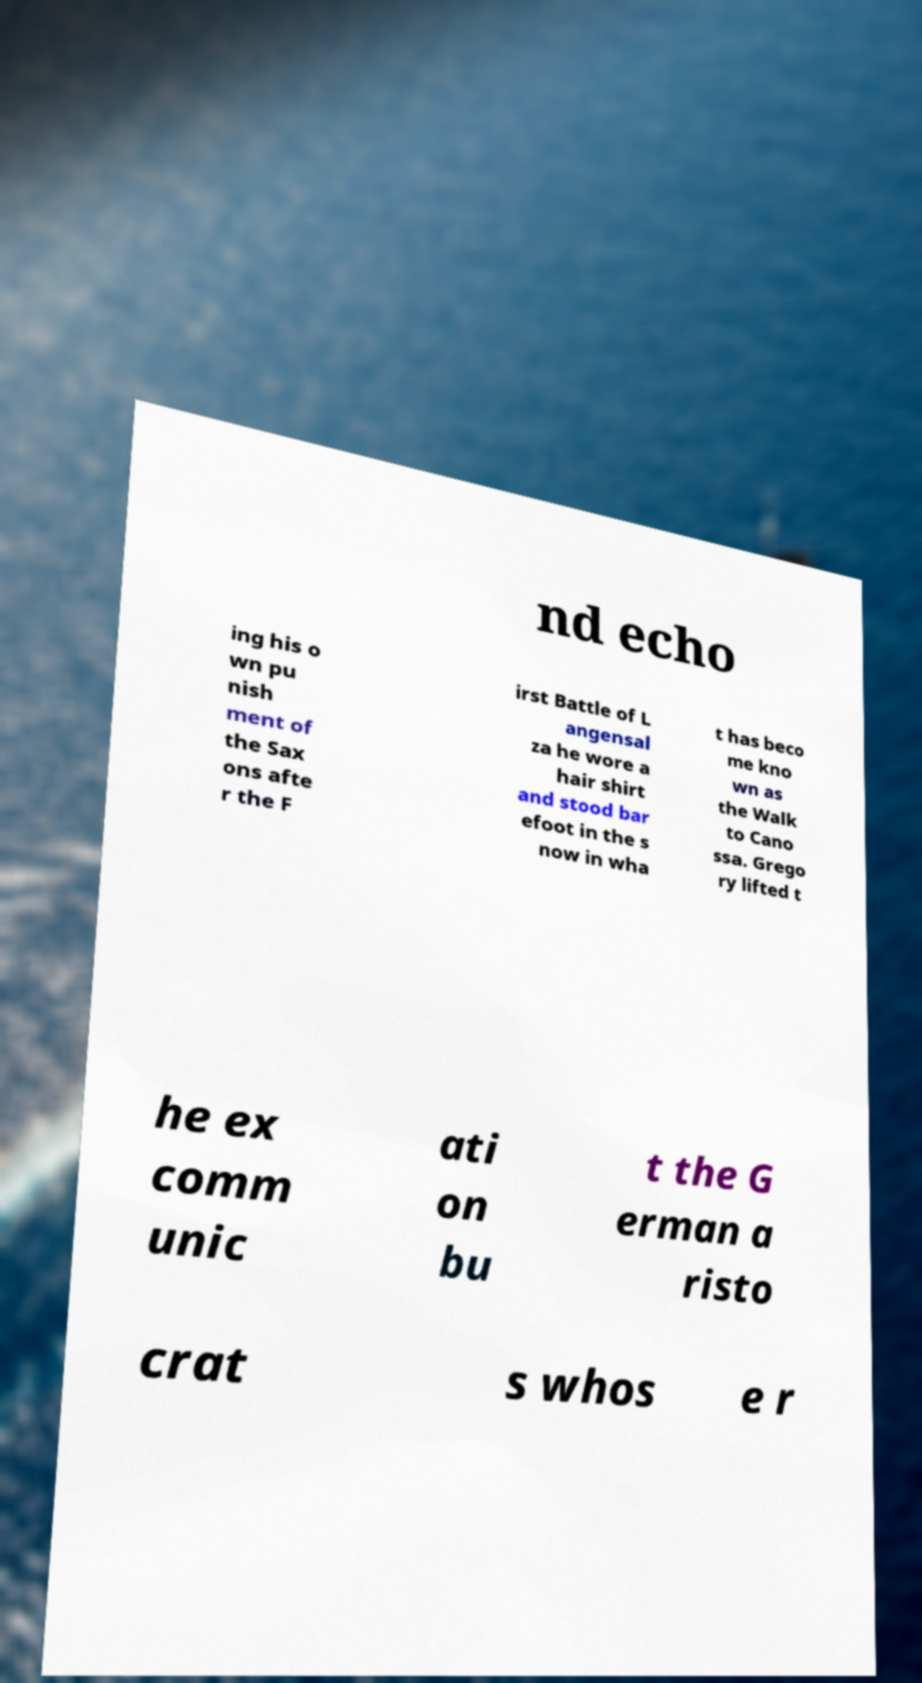Can you read and provide the text displayed in the image?This photo seems to have some interesting text. Can you extract and type it out for me? nd echo ing his o wn pu nish ment of the Sax ons afte r the F irst Battle of L angensal za he wore a hair shirt and stood bar efoot in the s now in wha t has beco me kno wn as the Walk to Cano ssa. Grego ry lifted t he ex comm unic ati on bu t the G erman a risto crat s whos e r 